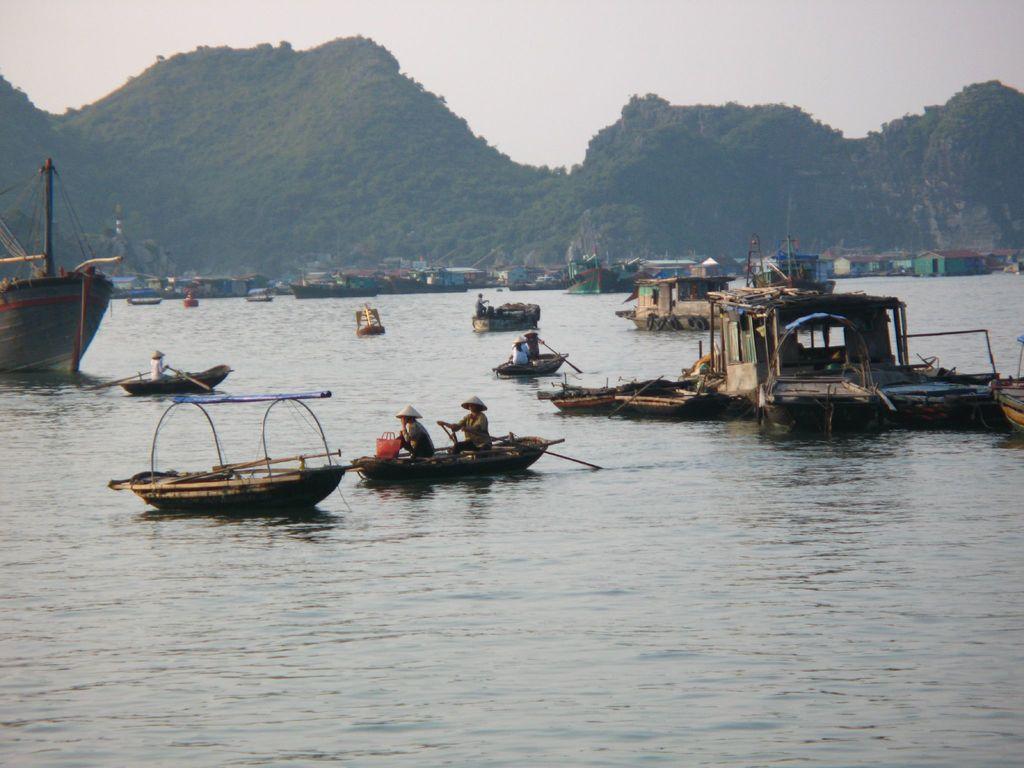Could you give a brief overview of what you see in this image? In this image, I can see few people sitting on the boats and holding paddles, which are on the water. In the background, there hills and the sky. 